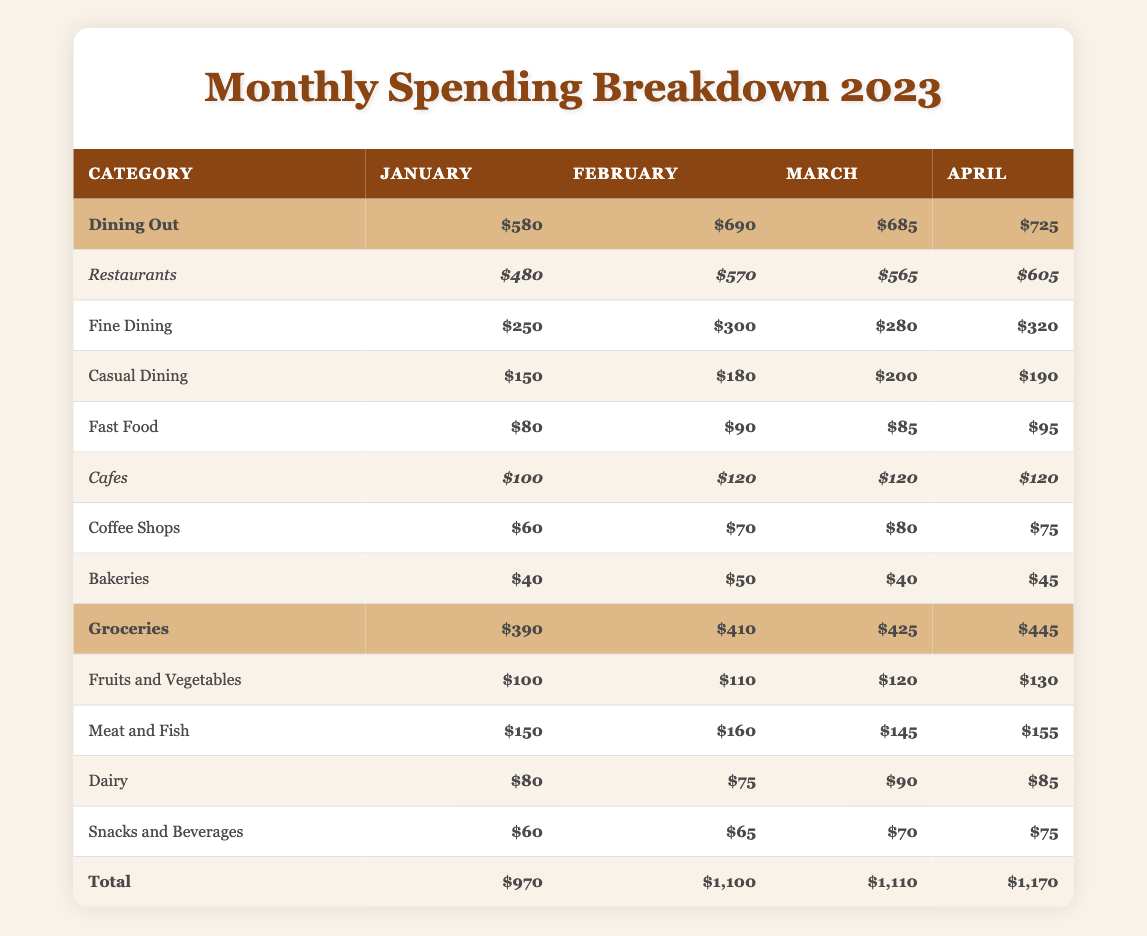What was the total amount spent on dining out in March? To find the total for dining out in March, we look at the "Dining Out" row for that month, which shows $685.
Answer: 685 Which month had the highest spending on groceries? Looking at the Grocery category, the highest amount is in April at $445.
Answer: April What is the combined spending on Fast Food in January and February? In January, the spending on Fast Food is $80 and in February it's $90. Adding these, $80 + $90 = $170.
Answer: 170 Is the spending on Fine Dining higher than on Casual Dining in all months? In January ($250 vs. $150), February ($300 vs. $180), March ($280 vs. $200), and April ($320 vs. $190), Fine Dining is higher in every month.
Answer: Yes In March, what is the difference in spending between Meat and Fish and Dairy? The spending on Meat and Fish in March is $145, while Dairy is $90. The difference is $145 - $90 = $55.
Answer: 55 What was the total amount spent on Cafes in January? In January, the spending on Cafes is $100, which includes $60 for Coffee Shops and $40 for Bakeries. Therefore, the total remains $100.
Answer: 100 What is the average monthly spending on Groceries from January to April? To find the average, add the total spending on Groceries for these months: $390 + $410 + $425 + $445 = $1,670. Then divide by 4, which gives $1,670 / 4 = $417.5.
Answer: 417.5 Which month had the lowest total spending on dining out? By comparing the total spending for each month: January ($580), February ($690), March ($685), April ($725), January has the lowest total.
Answer: January What is the total spending on Snacks and Beverages across all months? For Snacks and Beverages: January is $60, February $65, March $70, and April $75. Summing these gives $60 + $65 + $70 + $75 = $270.
Answer: 270 